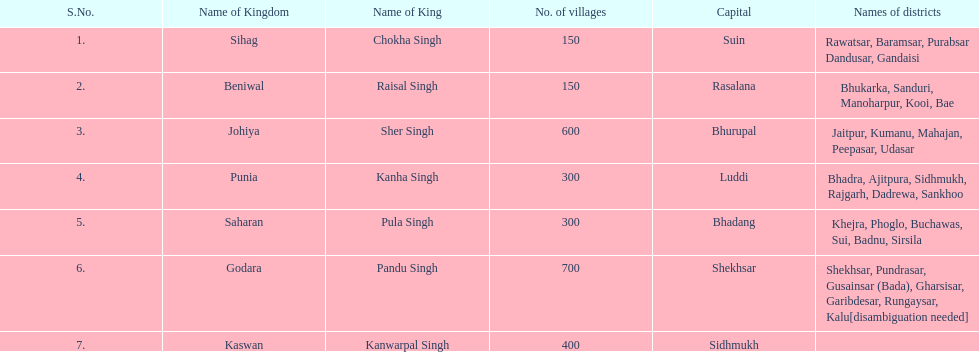How many districts are present in punia? 6. 